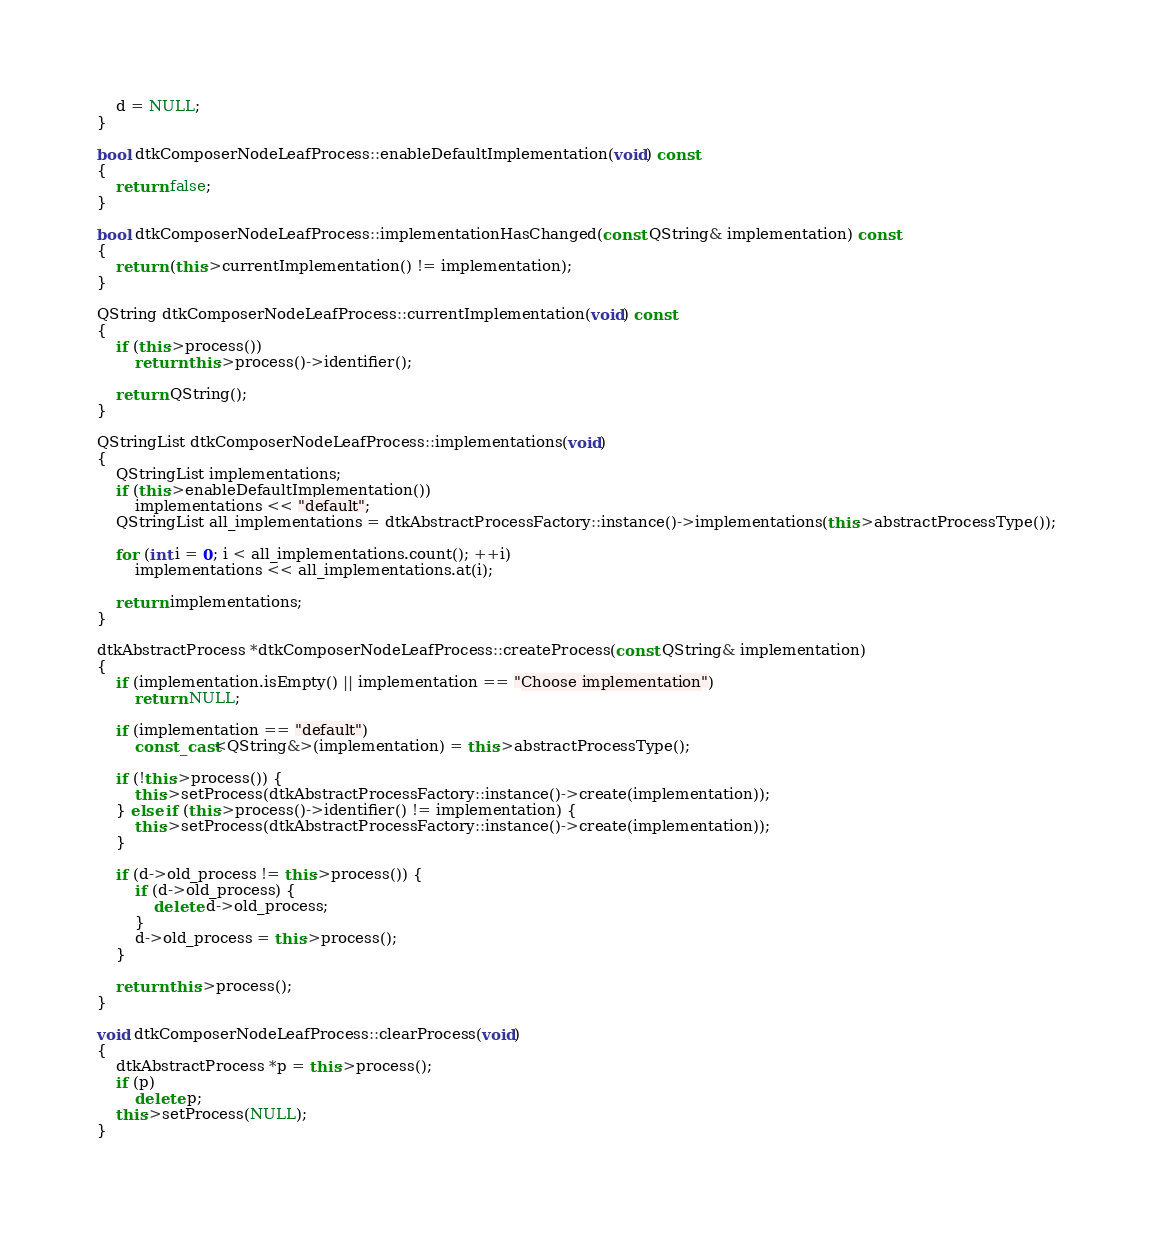Convert code to text. <code><loc_0><loc_0><loc_500><loc_500><_C++_>
    d = NULL;
}

bool dtkComposerNodeLeafProcess::enableDefaultImplementation(void) const
{
    return false;
}

bool dtkComposerNodeLeafProcess::implementationHasChanged(const QString& implementation) const
{
    return (this->currentImplementation() != implementation);
}

QString dtkComposerNodeLeafProcess::currentImplementation(void) const
{
    if (this->process())
        return this->process()->identifier();

    return QString();
}

QStringList dtkComposerNodeLeafProcess::implementations(void)
{
    QStringList implementations;
    if (this->enableDefaultImplementation())
        implementations << "default";
    QStringList all_implementations = dtkAbstractProcessFactory::instance()->implementations(this->abstractProcessType());

    for (int i = 0; i < all_implementations.count(); ++i)
        implementations << all_implementations.at(i);

    return implementations;
}

dtkAbstractProcess *dtkComposerNodeLeafProcess::createProcess(const QString& implementation)
{
    if (implementation.isEmpty() || implementation == "Choose implementation")
        return NULL;

    if (implementation == "default")
        const_cast<QString&>(implementation) = this->abstractProcessType();
    
    if (!this->process()) {
        this->setProcess(dtkAbstractProcessFactory::instance()->create(implementation));
    } else if (this->process()->identifier() != implementation) {
        this->setProcess(dtkAbstractProcessFactory::instance()->create(implementation));
    }

    if (d->old_process != this->process()) {
        if (d->old_process) {
            delete d->old_process;
        }
        d->old_process = this->process();
    }

    return this->process();
}

void dtkComposerNodeLeafProcess::clearProcess(void)
{
    dtkAbstractProcess *p = this->process();
    if (p)
        delete p;
    this->setProcess(NULL);
}
</code> 